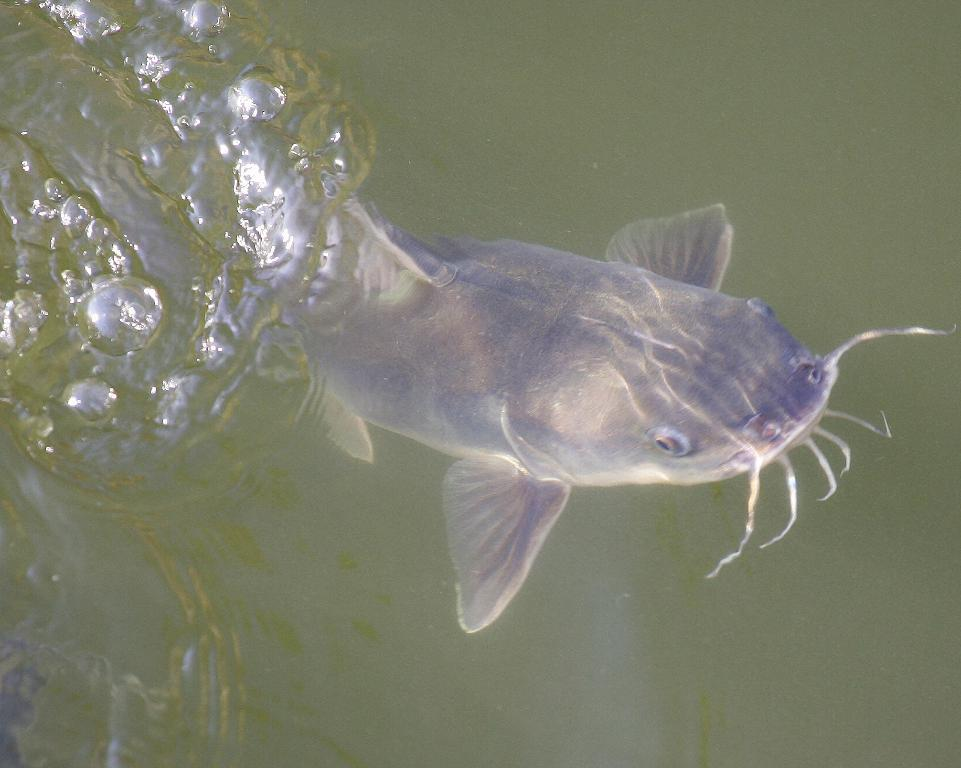What type of animals can be seen in the image? There are fish in the image. Where are the fish located? The fish are in the water. What type of shoe can be seen in the image? There is no shoe present in the image; it features fish in the water. What question is being asked by the fish in the image? There is no indication that the fish are asking any questions in the image. 